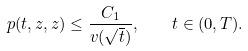<formula> <loc_0><loc_0><loc_500><loc_500>p ( t , z , z ) \leq \frac { C _ { 1 } } { v ( \sqrt { t } ) } , \quad t \in ( 0 , T ) .</formula> 